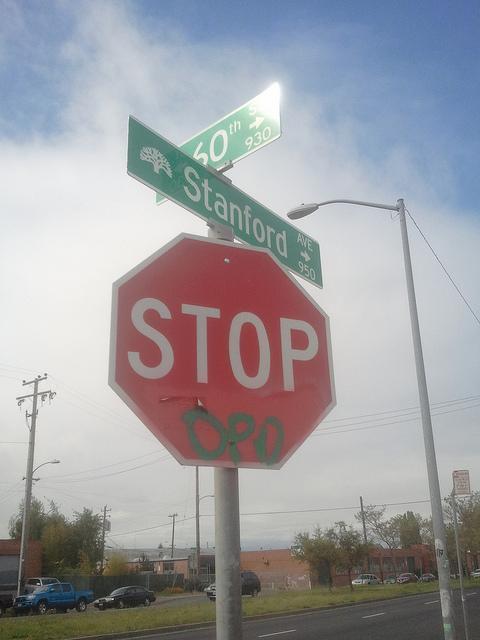How many hand-holding people are short?
Give a very brief answer. 0. 